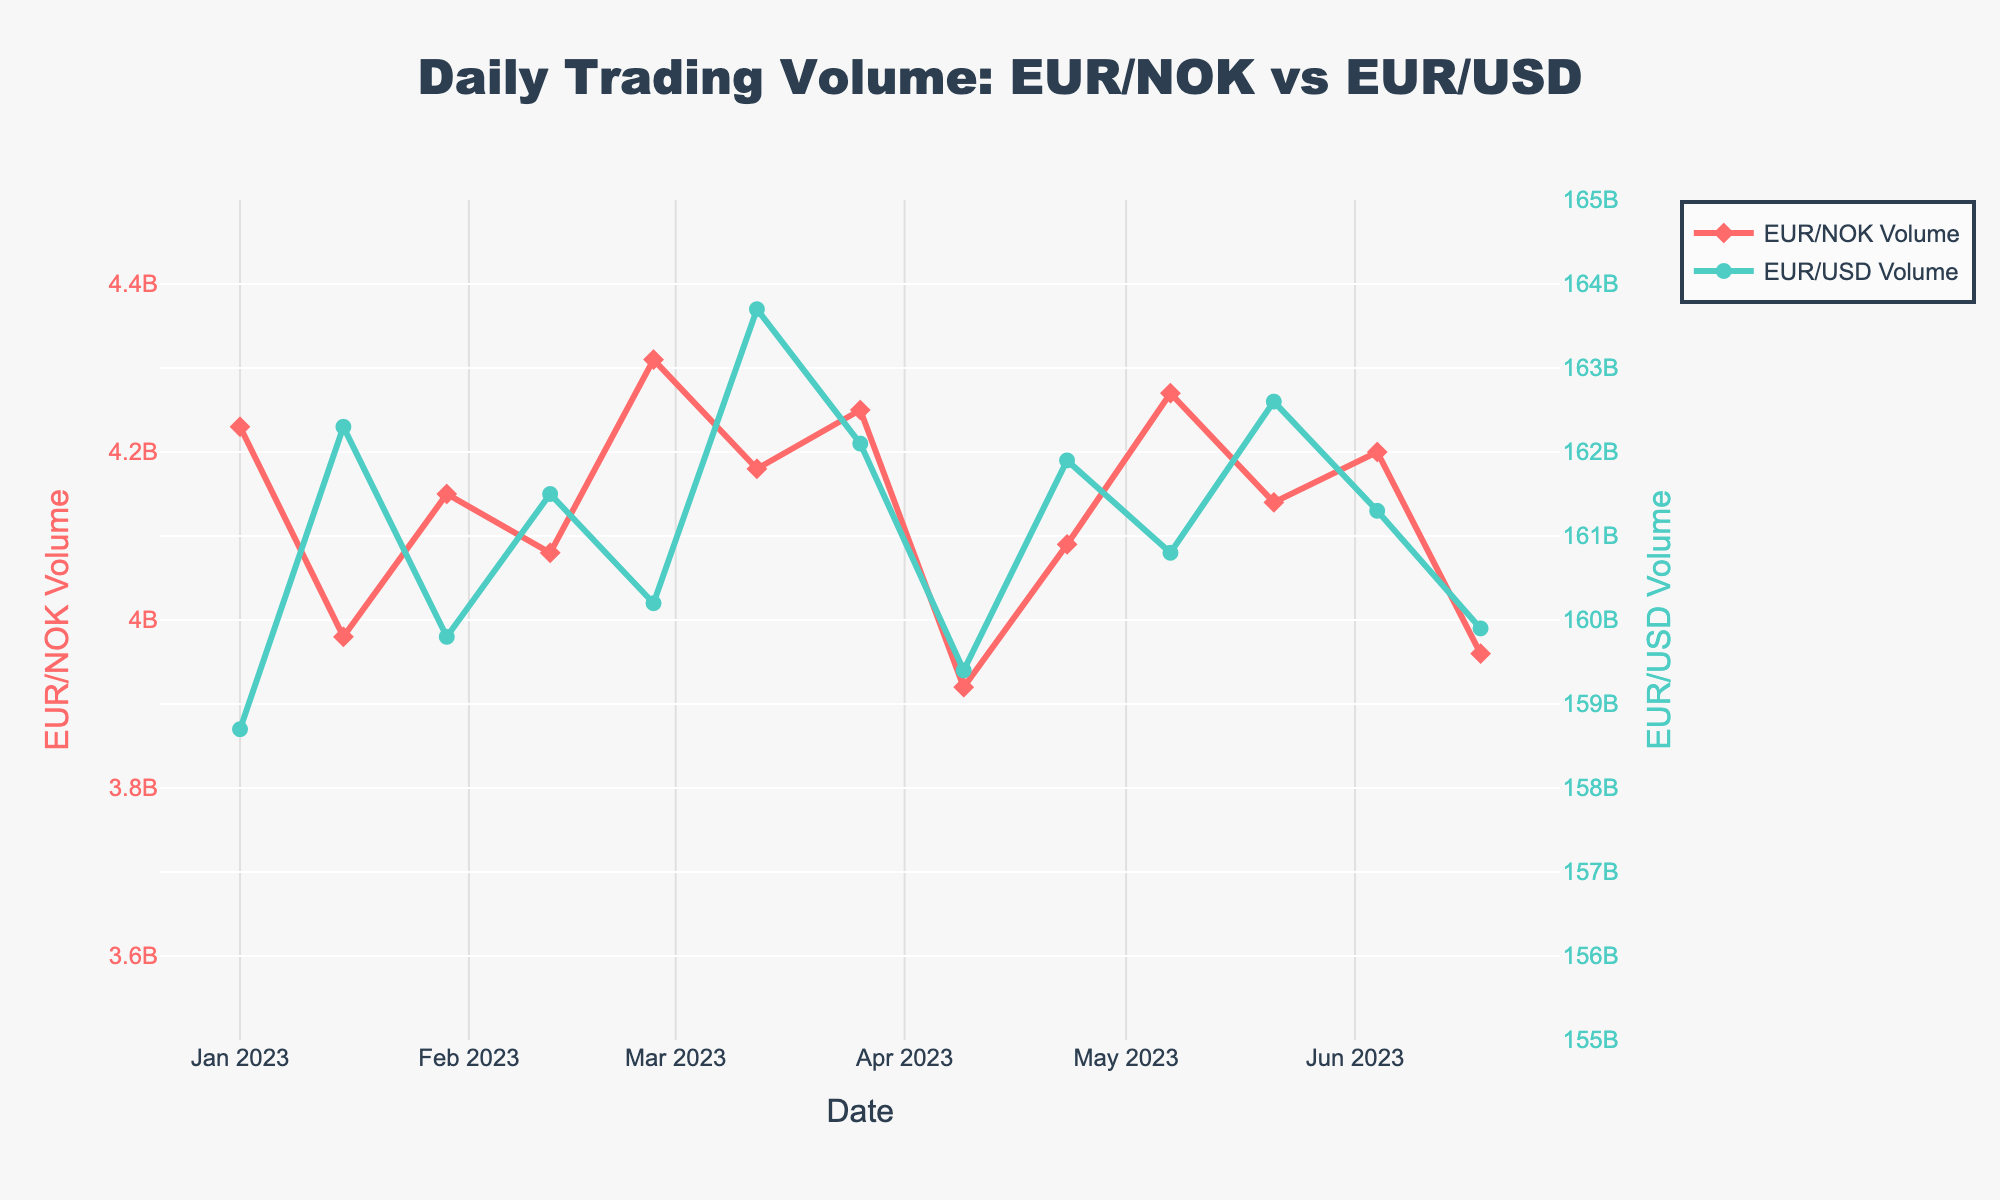What is the general trend in EUR/NOK trading volume over the 6 months? The EUR/NOK trading volume shows minor fluctuations but generally remains within a small range around 4.2 billion, with some higher peaks like at the end of February and early May.
Answer: Slight fluctuations within a range around 4.2 billion Over the six months, is there a specific date where the EUR/USD trading volume is at its maximum? By examining the plot, the highest EUR/USD trading volume across the six months appears to be around mid-March, specifically on March 12, reaching approximately 163.7 billion.
Answer: March 12 What is the approximate difference in trading volume between EUR/NOK and EUR/USD on January 15? On January 15, the trading volume for EUR/NOK is approximately 3.98 billion, while for EUR/USD, it is approximately 162.3 billion. The difference is 162.3 billion - 3.98 billion.
Answer: Approximately 158.32 billion During which month does EUR/USD show the least trading volume? Looking at the plot, the least trading volume for EUR/USD appears to be around early April, specifically on April 9, when it is about 159.4 billion.
Answer: April Which currency pair shows greater variability in trading volume over the 6 months? Analyzing the plots, the EUR/USD shows higher variability, with trading volumes fluctuating widely between 158.7 and 163.7 billion, compared to EUR/NOK's narrower range of 3.92 to 4.31 billion.
Answer: EUR/USD Is there a time period where both EUR/NOK and EUR/USD volumes increase simultaneously? By observing the trends, towards the end of February, specifically by February 26, both EUR/NOK and EUR/USD volumes increase, with EUR/NOK reaching around 4.31 billion and EUR/USD around 160.2 billion.
Answer: End of February How does the trading volume of EUR/USD on June 18 compare to that of EUR/NOK on the same date? On June 18, the trading volume for EUR/USD is approximately 159.9 billion, whereas for EUR/NOK, it is around 3.96 billion. The EUR/USD volume is significantly higher.
Answer: EUR/USD volume is significantly higher What can be inferred about the general pattern of EUR/USD trading volume fluctuations? The EUR/USD trading volume has high variability over the months, showing several peaks, with the highest being in mid-March and some lower points in early April and mid-June.
Answer: High variability with notable peaks and troughs Compare the trading volumes on the first and last dates in the dataset. On January 1, the volume for EUR/NOK is 4.23 billion and for EUR/USD is 158.7 billion. On June 18, the volume for EUR/NOK is 3.96 billion and for EUR/USD is 159.9 billion. There is a slight decrease for EUR/NOK and a slight increase for EUR/USD.
Answer: EUR/NOK slightly decreased, EUR/USD slightly increased How does the visual representation enhance the understanding of the volume differences between the two currency pairs? The use of different colors and symbols (diamonds for EUR/NOK in red and circles for EUR/USD in green) makes it clear and easy to distinguish the trading volumes of the two pairs. The dual y-axes also enable direct comparison on the same plot.
Answer: Enhances clarity and comparisonability 